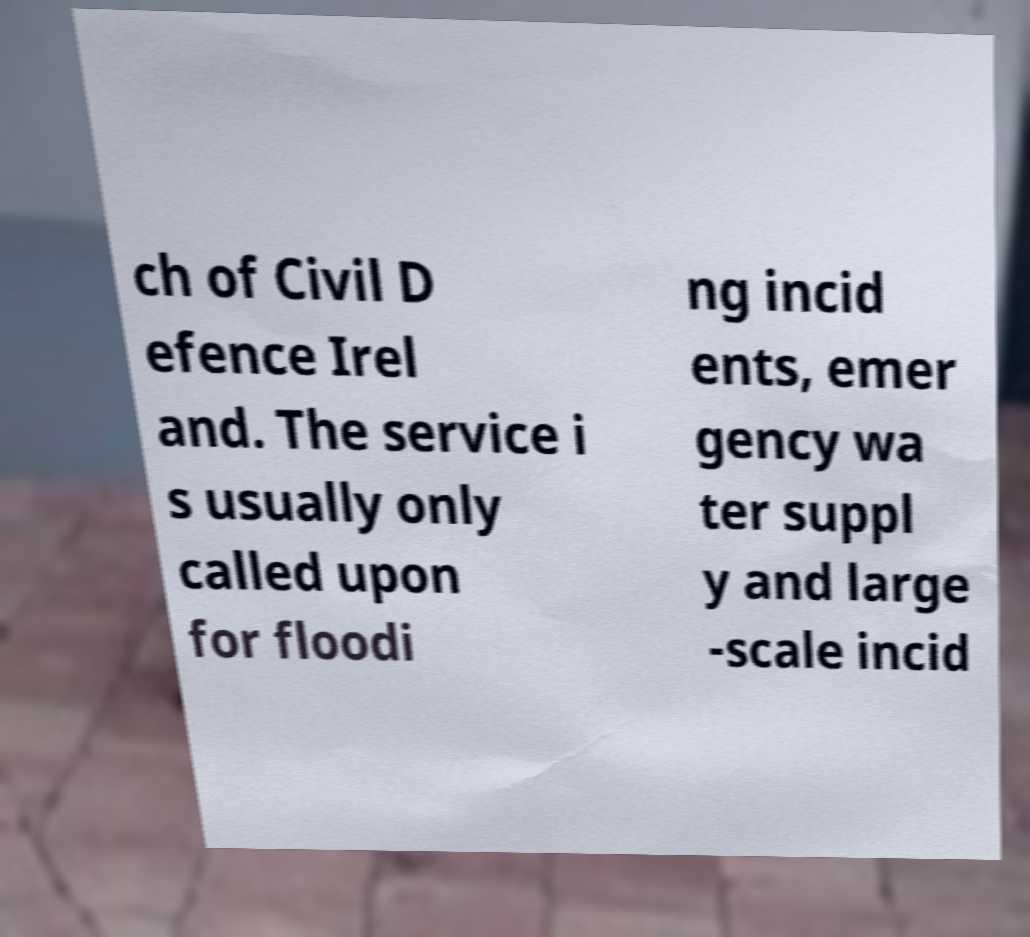Please read and relay the text visible in this image. What does it say? ch of Civil D efence Irel and. The service i s usually only called upon for floodi ng incid ents, emer gency wa ter suppl y and large -scale incid 